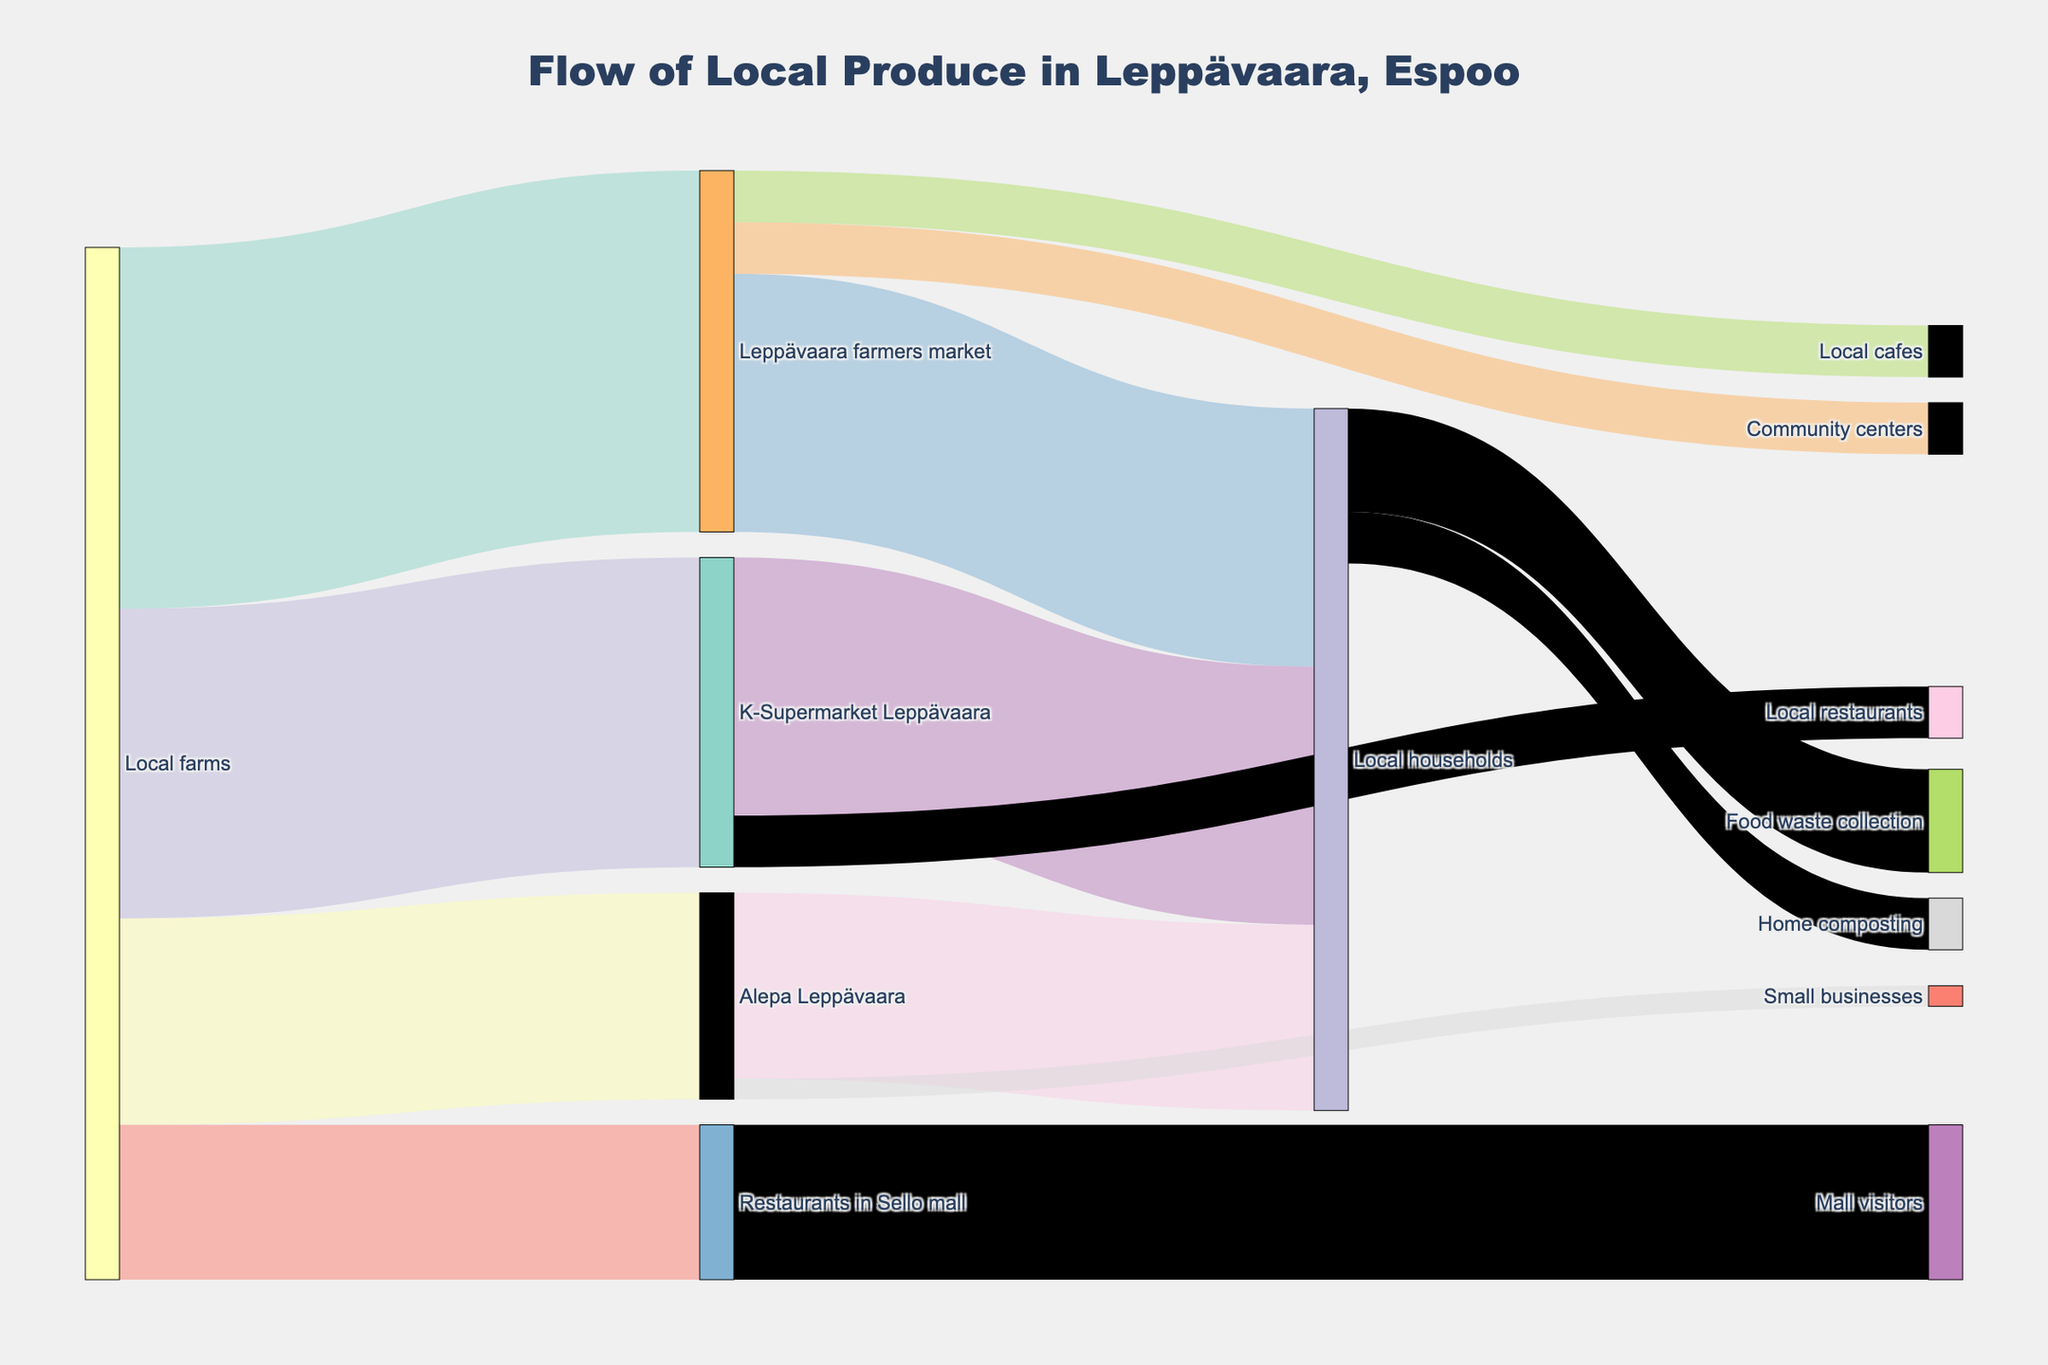What is the title of the figure? The title of the figure is displayed at the top and reads "Flow of Local Produce in Leppävaara, Espoo."
Answer: Flow of Local Produce in Leppävaara, Espoo Which location receives the most local produce from local farms? By looking at the widths of the flows from "Local farms," the widest flow goes to "Leppävaara farmers market," which has a value of 350.
Answer: Leppävaara farmers market How much local produce is distributed to local households from the Leppävaara farmers market? From the connections originating from "Leppävaara farmers market," the flow to "Local households" has a value of 250.
Answer: 250 Which location distributes the least amount of local produce to local cafes? From the flows, "Leppävaara farmers market" distributes 50 units to local cafes, and no other location has a distribution to local cafes, so it is the only and thus the least distributor.
Answer: Leppävaara farmers market How much local produce is sent from Alepa Leppävaara to small businesses? The flow from "Alepa Leppävaara" to "Small businesses" shows a value of 20 units.
Answer: 20 What is the total amount of local produce distributed to local households from all sources? Add the values of flows to "Local households": 250 (Leppävaara farmers market) + 180 (Alepa Leppävaara) + 250 (K-Supermarket Leppävaara) = 680.
Answer: 680 Which two destinations receive produce from K-Supermarket Leppävaara? The flows from "K-Supermarket Leppävaara" lead to "Local households" and "Local restaurants."
Answer: Local households, Local restaurants What percentage of produce sent to local households is collected as food waste? The flow from "Local households" to "Food waste collection" is 100. The total flow to "Local households" is 680. So, the percentage is (100 / 680) * 100 = 14.71%.
Answer: 14.71% Which location receives local produce but does not send any onward? By observing the flows, "Mall visitors" only receive produce from "Restaurants in Sello mall" and do not send any onward.
Answer: Mall visitors 